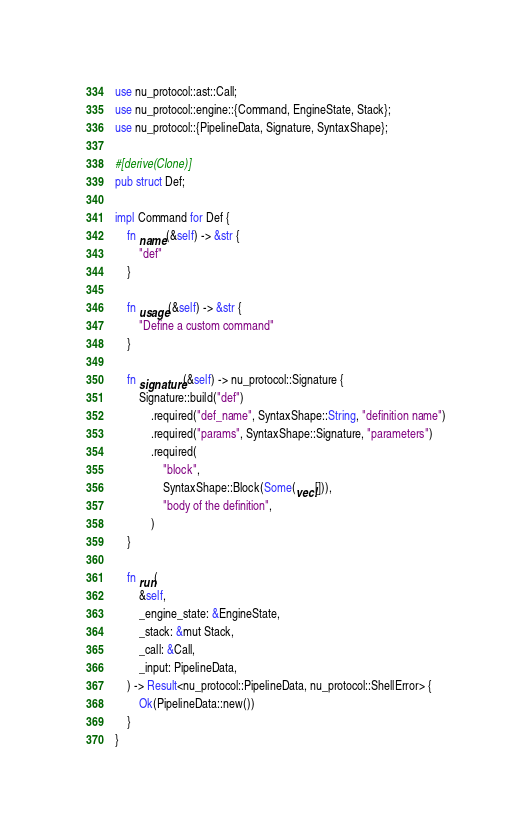Convert code to text. <code><loc_0><loc_0><loc_500><loc_500><_Rust_>use nu_protocol::ast::Call;
use nu_protocol::engine::{Command, EngineState, Stack};
use nu_protocol::{PipelineData, Signature, SyntaxShape};

#[derive(Clone)]
pub struct Def;

impl Command for Def {
    fn name(&self) -> &str {
        "def"
    }

    fn usage(&self) -> &str {
        "Define a custom command"
    }

    fn signature(&self) -> nu_protocol::Signature {
        Signature::build("def")
            .required("def_name", SyntaxShape::String, "definition name")
            .required("params", SyntaxShape::Signature, "parameters")
            .required(
                "block",
                SyntaxShape::Block(Some(vec![])),
                "body of the definition",
            )
    }

    fn run(
        &self,
        _engine_state: &EngineState,
        _stack: &mut Stack,
        _call: &Call,
        _input: PipelineData,
    ) -> Result<nu_protocol::PipelineData, nu_protocol::ShellError> {
        Ok(PipelineData::new())
    }
}
</code> 